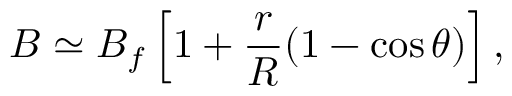<formula> <loc_0><loc_0><loc_500><loc_500>B \simeq B _ { f } \left [ 1 + \frac { r } { R } ( 1 - \cos \theta ) \right ] ,</formula> 